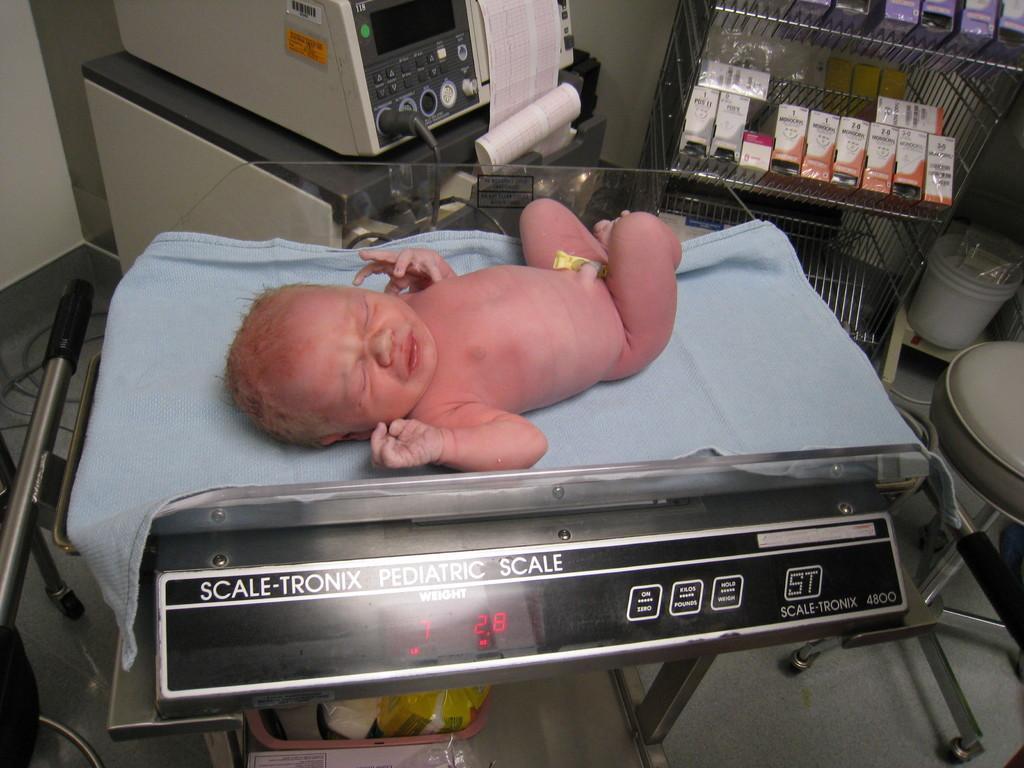Can you describe this image briefly? In the image we can see a baby lying, this is a weight machine, paper, box, rack, stool, dustbin and a floor. 